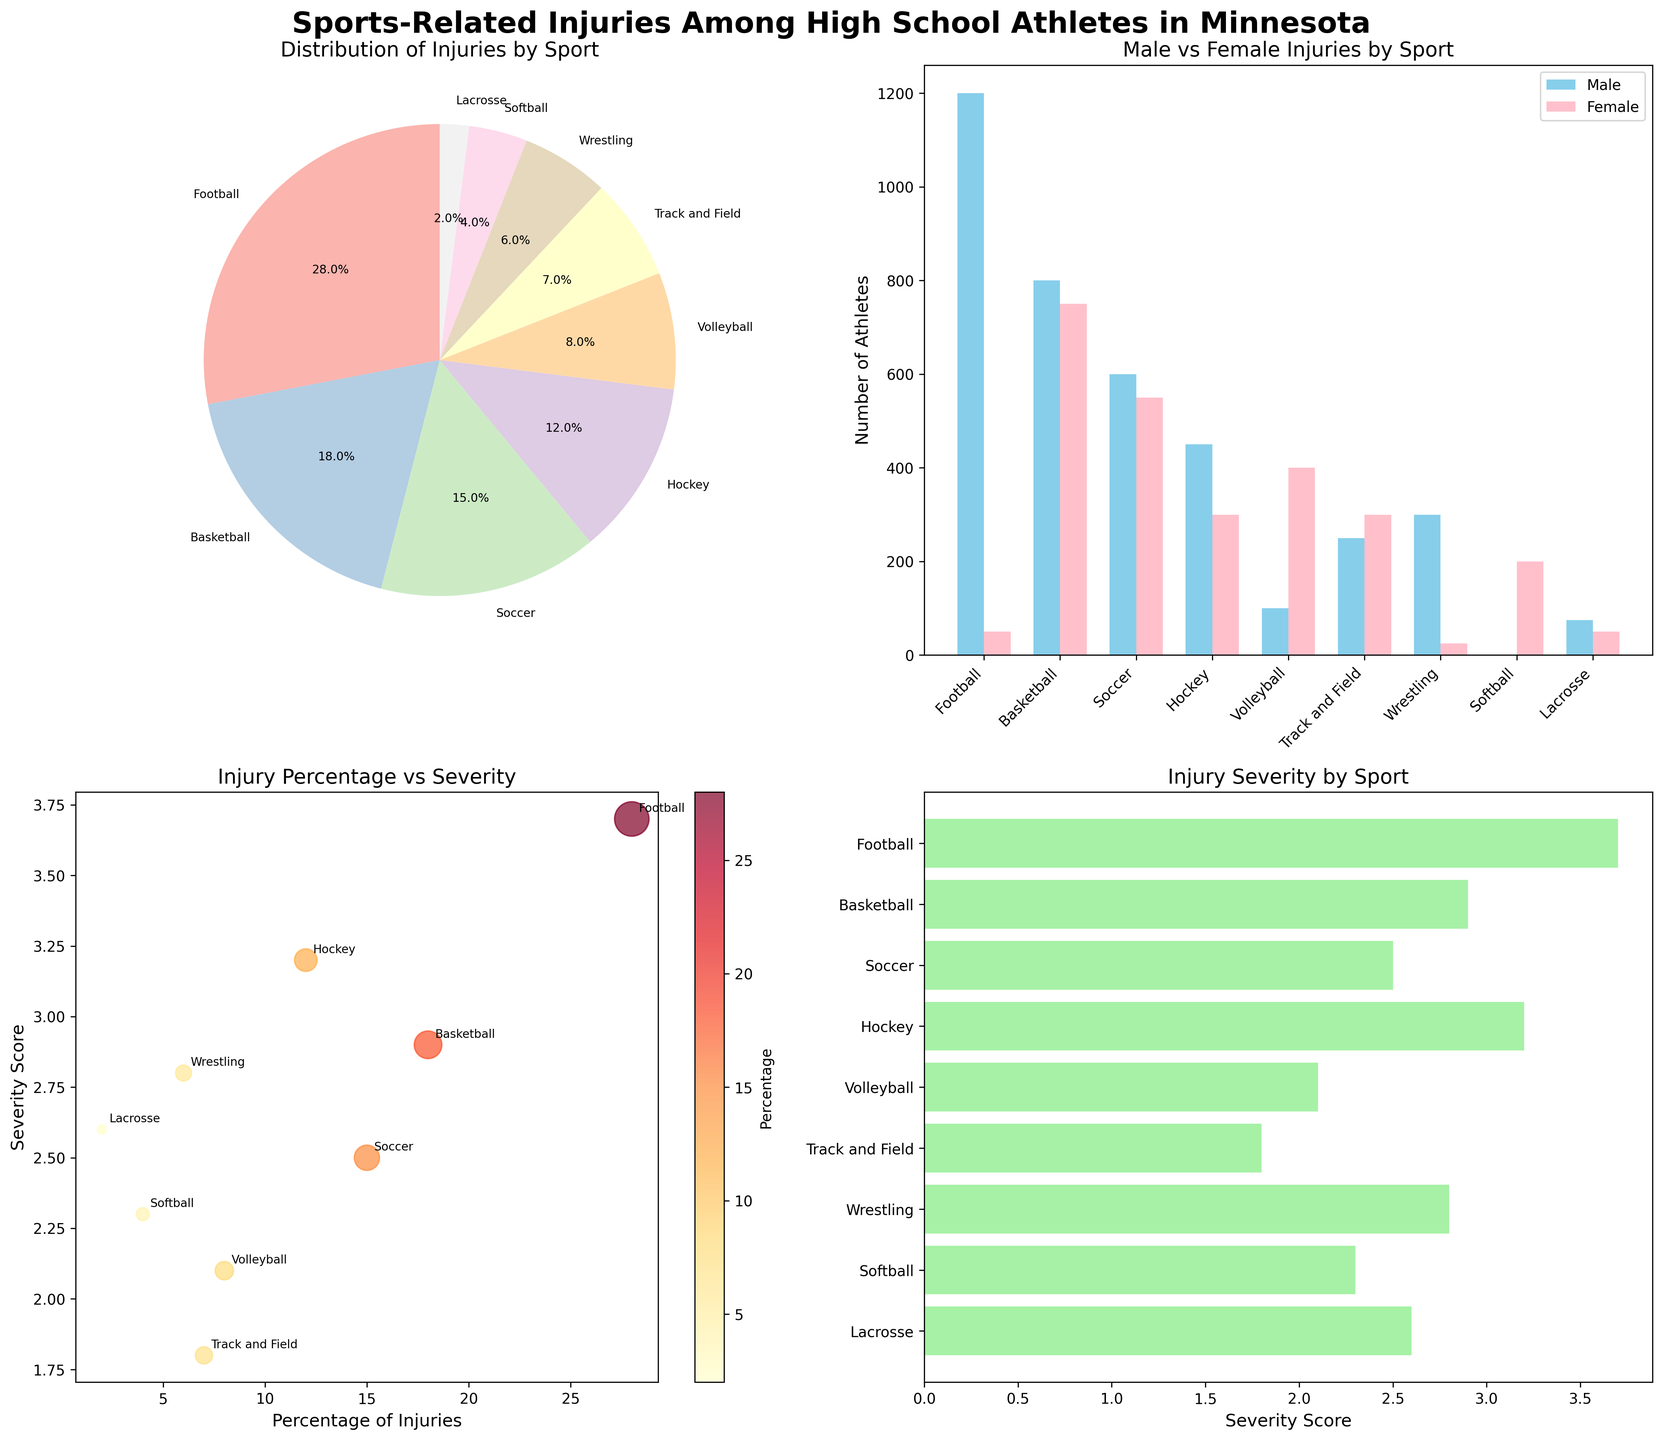What's the sport with the highest percentage of injuries? By looking at the pie chart, we can see that Football has the largest slice of the pie, representing 28% of injuries.
Answer: Football How many total male and female athletes were injured in basketball? From the bar chart, the number of injured male and female basketball players can be summed up. Males injured = 800. Females injured = 750. Total = 800 + 750 = 1550.
Answer: 1550 Which sport has a higher severity score, soccer or basketball? Looking at the scatter plot or horizontal bar chart, the severity score for Soccer is 2.5 and for Basketball is 2.9. Therefore, Basketball has a higher severity score.
Answer: Basketball What's the relationship between the percentage of injuries and severity score for football? Observing the scatter plot, Football has a percentage of 28% and a corresponding severity score of 3.7.
Answer: 28% and 3.7 How does the number of injuries in wrestling compare between males and females? Referring to the bar chart, Wrestling shows 300 males and 25 female injuries. Hence, there are significantly more male injuries than female injuries in wrestling.
Answer: More male injuries Which sport has the highest severity score, and what is it? Checking the horizontal bar chart, the sport with the highest severity score is Football at 3.7.
Answer: Football, 3.7 How do injuries in Track and Field compare to those in Hockey in terms of the number of male athletes? From the bar chart, Track and Field has 250 injured male athletes, while Hockey has 450. Therefore, Hockey has more injured male athletes than Track and Field.
Answer: More in Hockey What's the average severity score across all sports? The severity scores across all sports are summed (3.7 + 2.9 + 2.5 + 3.2 + 2.1 + 1.8 + 2.8 + 2.3 + 2.6) to get 24.9. Divided by the number of sports (9), the average is 24.9 / 9.
Answer: 2.77 What's the difference in injury severity scores between the sport with the highest and the sport with the lowest severity? The highest severity score is 3.7 (Football) and the lowest is 1.8 (Track and Field). The difference is 3.7 - 1.8.
Answer: 1.9 